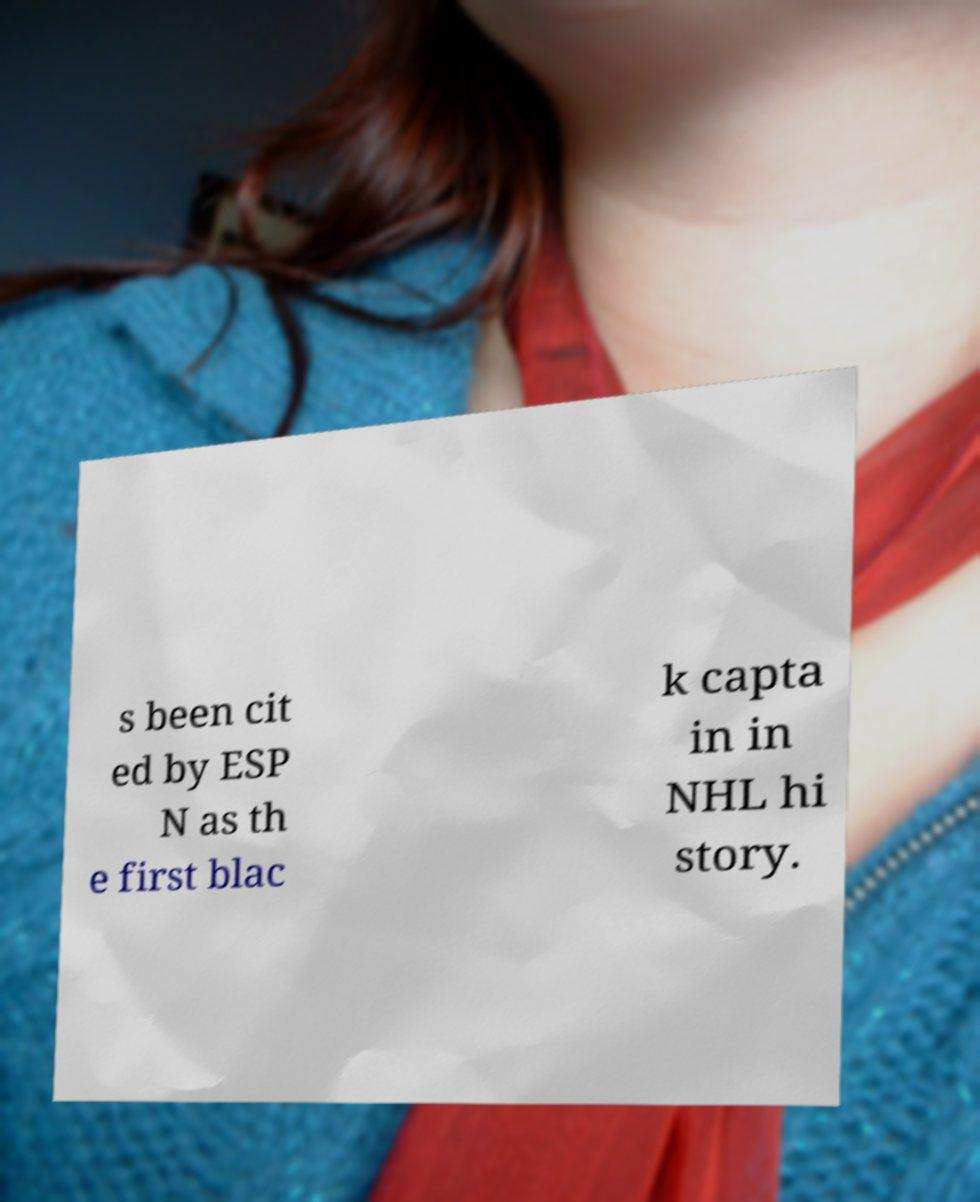Could you extract and type out the text from this image? s been cit ed by ESP N as th e first blac k capta in in NHL hi story. 